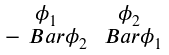Convert formula to latex. <formula><loc_0><loc_0><loc_500><loc_500>\begin{smallmatrix} \phi _ { 1 } & \phi _ { 2 } \\ - \ B a r { \phi } _ { 2 } & \ B a r { \phi } _ { 1 } \end{smallmatrix}</formula> 